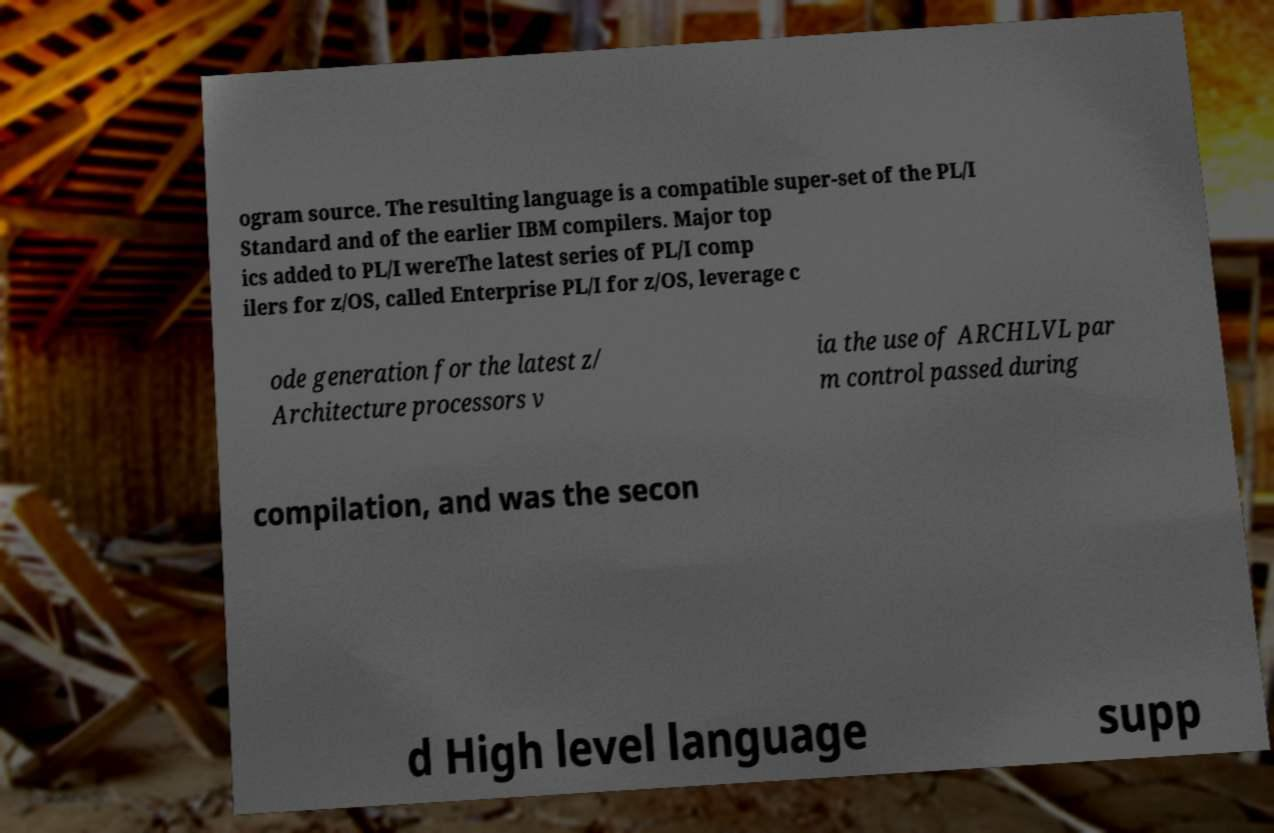Can you accurately transcribe the text from the provided image for me? ogram source. The resulting language is a compatible super-set of the PL/I Standard and of the earlier IBM compilers. Major top ics added to PL/I wereThe latest series of PL/I comp ilers for z/OS, called Enterprise PL/I for z/OS, leverage c ode generation for the latest z/ Architecture processors v ia the use of ARCHLVL par m control passed during compilation, and was the secon d High level language supp 